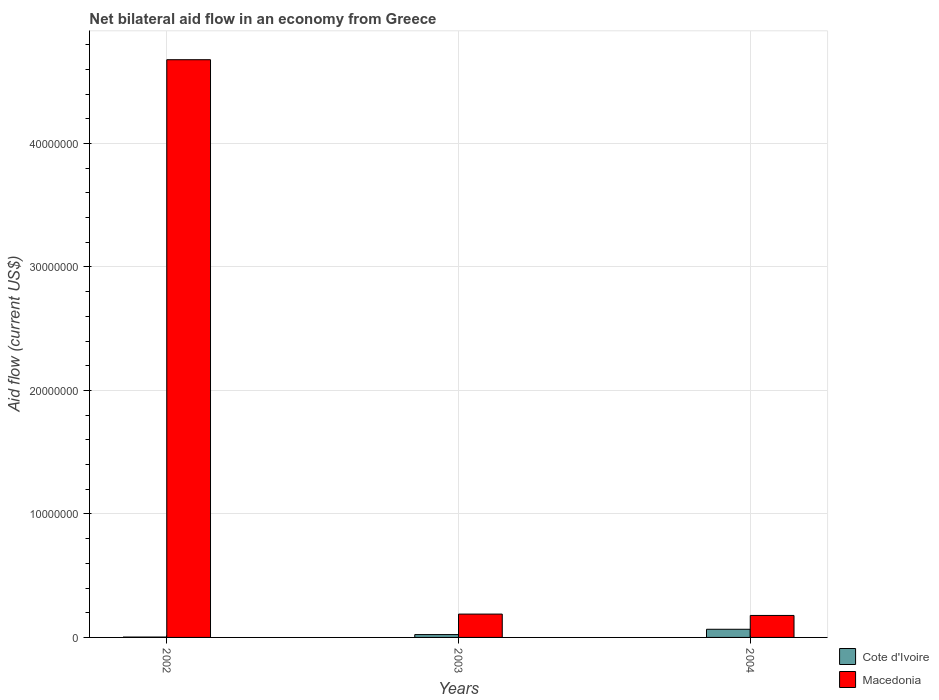How many bars are there on the 3rd tick from the left?
Keep it short and to the point. 2. How many bars are there on the 1st tick from the right?
Offer a very short reply. 2. What is the label of the 3rd group of bars from the left?
Your answer should be very brief. 2004. In how many cases, is the number of bars for a given year not equal to the number of legend labels?
Your response must be concise. 0. What is the net bilateral aid flow in Macedonia in 2002?
Your answer should be compact. 4.68e+07. Across all years, what is the maximum net bilateral aid flow in Macedonia?
Keep it short and to the point. 4.68e+07. Across all years, what is the minimum net bilateral aid flow in Cote d'Ivoire?
Your answer should be very brief. 3.00e+04. In which year was the net bilateral aid flow in Macedonia maximum?
Offer a terse response. 2002. What is the total net bilateral aid flow in Macedonia in the graph?
Keep it short and to the point. 5.04e+07. What is the difference between the net bilateral aid flow in Cote d'Ivoire in 2002 and that in 2004?
Make the answer very short. -6.30e+05. What is the difference between the net bilateral aid flow in Macedonia in 2003 and the net bilateral aid flow in Cote d'Ivoire in 2004?
Provide a succinct answer. 1.23e+06. What is the average net bilateral aid flow in Macedonia per year?
Make the answer very short. 1.68e+07. In the year 2002, what is the difference between the net bilateral aid flow in Cote d'Ivoire and net bilateral aid flow in Macedonia?
Keep it short and to the point. -4.68e+07. What is the ratio of the net bilateral aid flow in Cote d'Ivoire in 2003 to that in 2004?
Make the answer very short. 0.35. What is the difference between the highest and the second highest net bilateral aid flow in Macedonia?
Keep it short and to the point. 4.49e+07. What is the difference between the highest and the lowest net bilateral aid flow in Cote d'Ivoire?
Give a very brief answer. 6.30e+05. Is the sum of the net bilateral aid flow in Macedonia in 2002 and 2004 greater than the maximum net bilateral aid flow in Cote d'Ivoire across all years?
Keep it short and to the point. Yes. What does the 2nd bar from the left in 2002 represents?
Ensure brevity in your answer.  Macedonia. What does the 2nd bar from the right in 2003 represents?
Your answer should be very brief. Cote d'Ivoire. How many years are there in the graph?
Provide a succinct answer. 3. What is the difference between two consecutive major ticks on the Y-axis?
Make the answer very short. 1.00e+07. Are the values on the major ticks of Y-axis written in scientific E-notation?
Ensure brevity in your answer.  No. Does the graph contain grids?
Your response must be concise. Yes. Where does the legend appear in the graph?
Offer a terse response. Bottom right. How are the legend labels stacked?
Offer a very short reply. Vertical. What is the title of the graph?
Your answer should be very brief. Net bilateral aid flow in an economy from Greece. What is the label or title of the X-axis?
Provide a succinct answer. Years. What is the Aid flow (current US$) of Cote d'Ivoire in 2002?
Your answer should be very brief. 3.00e+04. What is the Aid flow (current US$) in Macedonia in 2002?
Offer a very short reply. 4.68e+07. What is the Aid flow (current US$) of Cote d'Ivoire in 2003?
Ensure brevity in your answer.  2.30e+05. What is the Aid flow (current US$) in Macedonia in 2003?
Offer a very short reply. 1.89e+06. What is the Aid flow (current US$) of Cote d'Ivoire in 2004?
Keep it short and to the point. 6.60e+05. What is the Aid flow (current US$) of Macedonia in 2004?
Make the answer very short. 1.78e+06. Across all years, what is the maximum Aid flow (current US$) in Macedonia?
Keep it short and to the point. 4.68e+07. Across all years, what is the minimum Aid flow (current US$) of Macedonia?
Provide a short and direct response. 1.78e+06. What is the total Aid flow (current US$) of Cote d'Ivoire in the graph?
Your answer should be compact. 9.20e+05. What is the total Aid flow (current US$) in Macedonia in the graph?
Give a very brief answer. 5.04e+07. What is the difference between the Aid flow (current US$) in Cote d'Ivoire in 2002 and that in 2003?
Provide a succinct answer. -2.00e+05. What is the difference between the Aid flow (current US$) of Macedonia in 2002 and that in 2003?
Offer a terse response. 4.49e+07. What is the difference between the Aid flow (current US$) of Cote d'Ivoire in 2002 and that in 2004?
Offer a very short reply. -6.30e+05. What is the difference between the Aid flow (current US$) of Macedonia in 2002 and that in 2004?
Ensure brevity in your answer.  4.50e+07. What is the difference between the Aid flow (current US$) of Cote d'Ivoire in 2003 and that in 2004?
Offer a very short reply. -4.30e+05. What is the difference between the Aid flow (current US$) of Cote d'Ivoire in 2002 and the Aid flow (current US$) of Macedonia in 2003?
Provide a succinct answer. -1.86e+06. What is the difference between the Aid flow (current US$) of Cote d'Ivoire in 2002 and the Aid flow (current US$) of Macedonia in 2004?
Offer a terse response. -1.75e+06. What is the difference between the Aid flow (current US$) of Cote d'Ivoire in 2003 and the Aid flow (current US$) of Macedonia in 2004?
Keep it short and to the point. -1.55e+06. What is the average Aid flow (current US$) in Cote d'Ivoire per year?
Provide a succinct answer. 3.07e+05. What is the average Aid flow (current US$) of Macedonia per year?
Provide a short and direct response. 1.68e+07. In the year 2002, what is the difference between the Aid flow (current US$) in Cote d'Ivoire and Aid flow (current US$) in Macedonia?
Your answer should be compact. -4.68e+07. In the year 2003, what is the difference between the Aid flow (current US$) of Cote d'Ivoire and Aid flow (current US$) of Macedonia?
Offer a terse response. -1.66e+06. In the year 2004, what is the difference between the Aid flow (current US$) of Cote d'Ivoire and Aid flow (current US$) of Macedonia?
Your response must be concise. -1.12e+06. What is the ratio of the Aid flow (current US$) of Cote d'Ivoire in 2002 to that in 2003?
Provide a succinct answer. 0.13. What is the ratio of the Aid flow (current US$) of Macedonia in 2002 to that in 2003?
Give a very brief answer. 24.75. What is the ratio of the Aid flow (current US$) in Cote d'Ivoire in 2002 to that in 2004?
Your answer should be very brief. 0.05. What is the ratio of the Aid flow (current US$) in Macedonia in 2002 to that in 2004?
Your answer should be compact. 26.28. What is the ratio of the Aid flow (current US$) of Cote d'Ivoire in 2003 to that in 2004?
Give a very brief answer. 0.35. What is the ratio of the Aid flow (current US$) in Macedonia in 2003 to that in 2004?
Offer a terse response. 1.06. What is the difference between the highest and the second highest Aid flow (current US$) in Cote d'Ivoire?
Give a very brief answer. 4.30e+05. What is the difference between the highest and the second highest Aid flow (current US$) of Macedonia?
Make the answer very short. 4.49e+07. What is the difference between the highest and the lowest Aid flow (current US$) of Cote d'Ivoire?
Make the answer very short. 6.30e+05. What is the difference between the highest and the lowest Aid flow (current US$) of Macedonia?
Offer a terse response. 4.50e+07. 